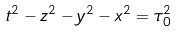Convert formula to latex. <formula><loc_0><loc_0><loc_500><loc_500>t ^ { 2 } - z ^ { 2 } - y ^ { 2 } - x ^ { 2 } = \tau _ { 0 } ^ { 2 }</formula> 